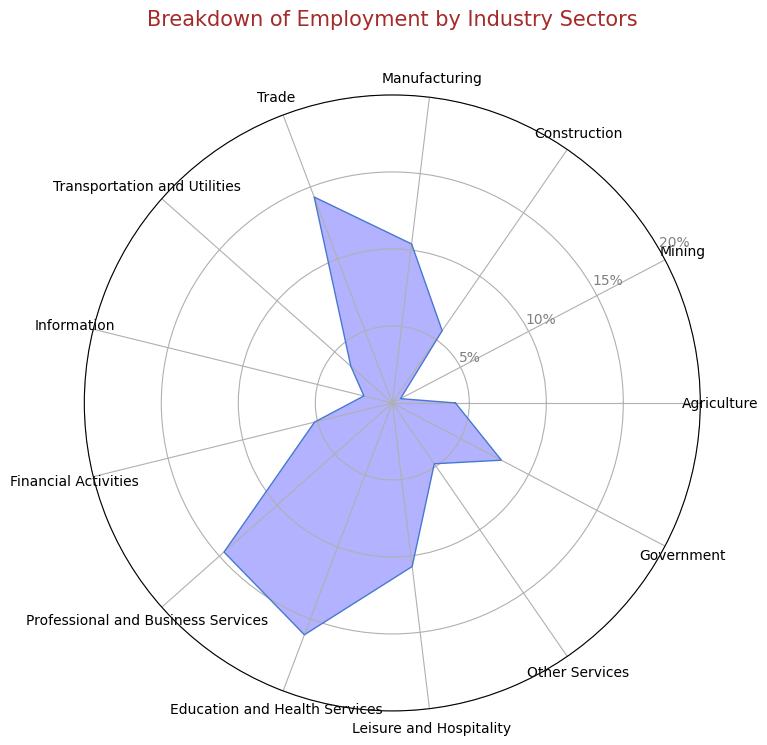Which industry sector has the largest percentage of employment? The sector with the largest percentage of employment will have the highest point on the radar chart. From the figure, the highest point is for Education and Health Services.
Answer: Education and Health Services Which sector contributes less, Mining or Information? The sector with a lower value will have a smaller length on the radar chart. From the figure, Mining has a lower percentage (0.6%) compared to Information (1.9%).
Answer: Mining What is the sum of the percentages of the three largest sectors? The three sectors with the largest contributions are Education and Health Services (16.1%), Professional and Business Services (14.6%), and Trade (14.3%). Adding these gives 16.1 + 14.6 + 14.3 = 45.0%.
Answer: 45.0% Which sector has a percentage closest to 5%? Looking for the point on the radar chart closest to the 5% ring, we find that Financial Activities (5.2%) and Construction (5.7%) are close, but Financial Activities (5.2%) is closer to 5%.
Answer: Financial Activities What is the difference in percentage between Manufacturing and Agriculture? From the radar chart, Manufacturing has 10.4% and Agriculture has 4.1%. The difference is 10.4 - 4.1 = 6.3%.
Answer: 6.3% Among Trade, Leisure and Hospitality, and Government, which has the smallest employment percentage? By comparing the positions of these sectors on the radar chart, it is clear that Government (8.0%) has a smaller percentage than Trade (14.3%) and Leisure and Hospitality (10.7%).
Answer: Government What is the average percentage of Information, Financial Activities, and Other Services? Add the percentages of Information (1.9%), Financial Activities (5.2%), and Other Services (4.8%), then divide by 3: (1.9 + 5.2 + 4.8) / 3 = 11.9 / 3 = 3.97%.
Answer: 3.97% Is the employment in Government less than twice the employment in Construction? Government employs 8.0% and Construction employs 5.7%. Twice the employment in Construction is 5.7 * 2 = 11.4%. Since 8.0% < 11.4%, the statement is true.
Answer: Yes Which sectors have an employment percentage between 10% and 15%? Identify the sectors that fall within the 10%-15% range on the radar chart: Manufacturing (10.4%), Trade (14.3%), and Leisure and Hospitality (10.7%).
Answer: Manufacturing, Trade, Leisure and Hospitality 